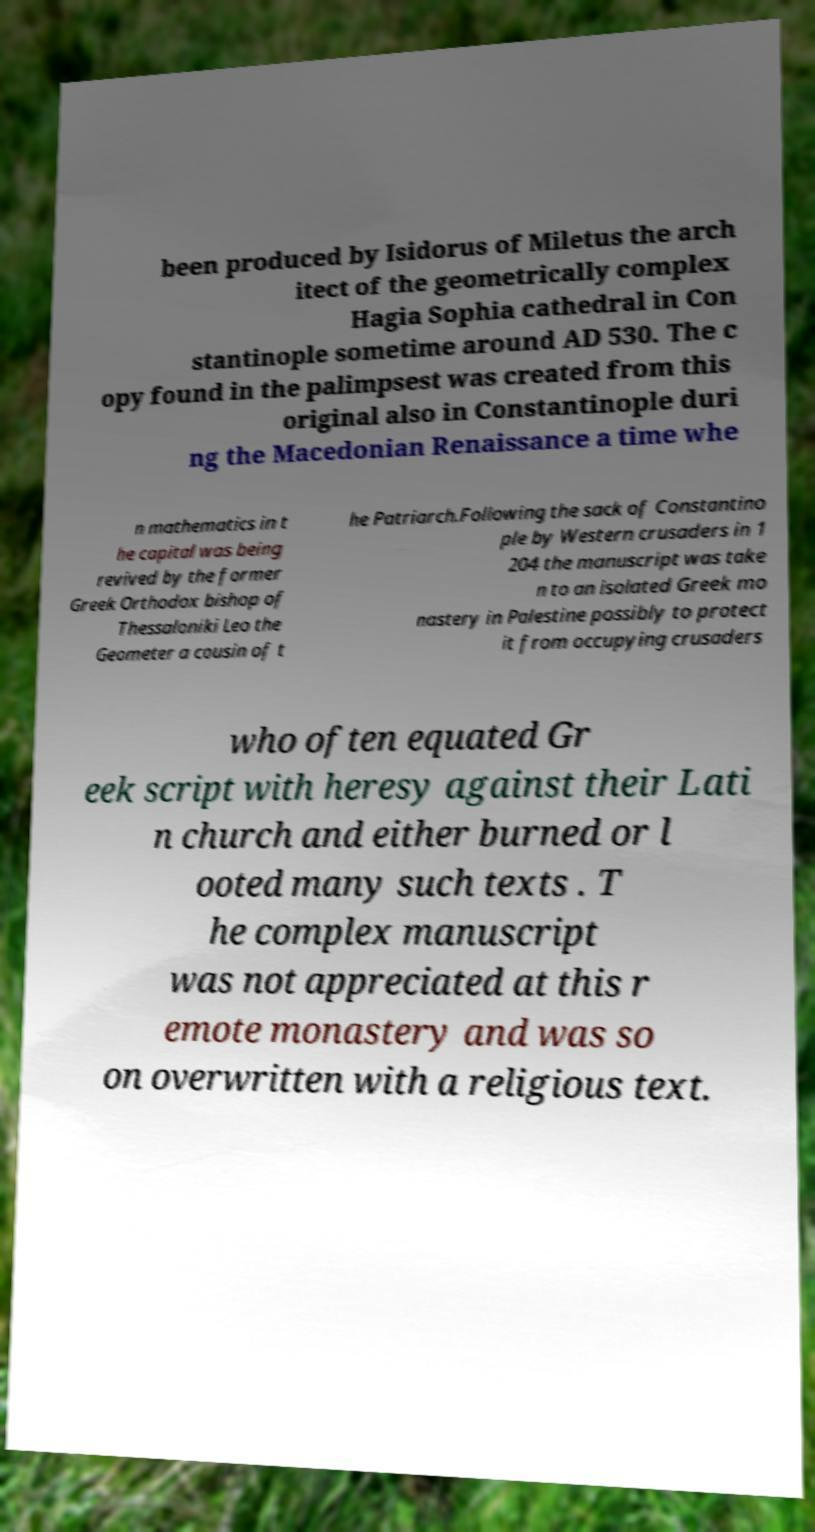There's text embedded in this image that I need extracted. Can you transcribe it verbatim? been produced by Isidorus of Miletus the arch itect of the geometrically complex Hagia Sophia cathedral in Con stantinople sometime around AD 530. The c opy found in the palimpsest was created from this original also in Constantinople duri ng the Macedonian Renaissance a time whe n mathematics in t he capital was being revived by the former Greek Orthodox bishop of Thessaloniki Leo the Geometer a cousin of t he Patriarch.Following the sack of Constantino ple by Western crusaders in 1 204 the manuscript was take n to an isolated Greek mo nastery in Palestine possibly to protect it from occupying crusaders who often equated Gr eek script with heresy against their Lati n church and either burned or l ooted many such texts . T he complex manuscript was not appreciated at this r emote monastery and was so on overwritten with a religious text. 